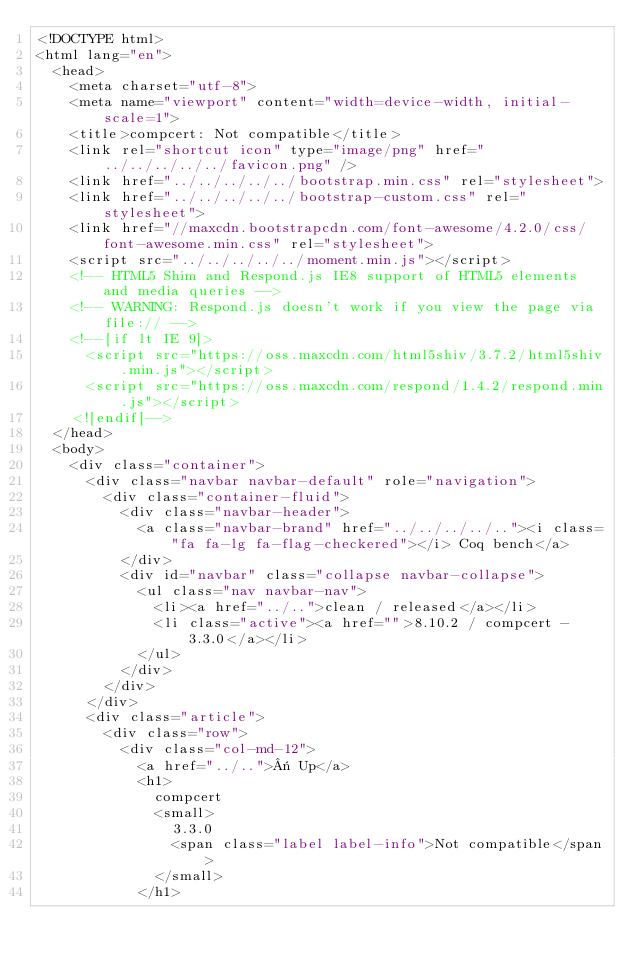Convert code to text. <code><loc_0><loc_0><loc_500><loc_500><_HTML_><!DOCTYPE html>
<html lang="en">
  <head>
    <meta charset="utf-8">
    <meta name="viewport" content="width=device-width, initial-scale=1">
    <title>compcert: Not compatible</title>
    <link rel="shortcut icon" type="image/png" href="../../../../../favicon.png" />
    <link href="../../../../../bootstrap.min.css" rel="stylesheet">
    <link href="../../../../../bootstrap-custom.css" rel="stylesheet">
    <link href="//maxcdn.bootstrapcdn.com/font-awesome/4.2.0/css/font-awesome.min.css" rel="stylesheet">
    <script src="../../../../../moment.min.js"></script>
    <!-- HTML5 Shim and Respond.js IE8 support of HTML5 elements and media queries -->
    <!-- WARNING: Respond.js doesn't work if you view the page via file:// -->
    <!--[if lt IE 9]>
      <script src="https://oss.maxcdn.com/html5shiv/3.7.2/html5shiv.min.js"></script>
      <script src="https://oss.maxcdn.com/respond/1.4.2/respond.min.js"></script>
    <![endif]-->
  </head>
  <body>
    <div class="container">
      <div class="navbar navbar-default" role="navigation">
        <div class="container-fluid">
          <div class="navbar-header">
            <a class="navbar-brand" href="../../../../.."><i class="fa fa-lg fa-flag-checkered"></i> Coq bench</a>
          </div>
          <div id="navbar" class="collapse navbar-collapse">
            <ul class="nav navbar-nav">
              <li><a href="../..">clean / released</a></li>
              <li class="active"><a href="">8.10.2 / compcert - 3.3.0</a></li>
            </ul>
          </div>
        </div>
      </div>
      <div class="article">
        <div class="row">
          <div class="col-md-12">
            <a href="../..">« Up</a>
            <h1>
              compcert
              <small>
                3.3.0
                <span class="label label-info">Not compatible</span>
              </small>
            </h1></code> 